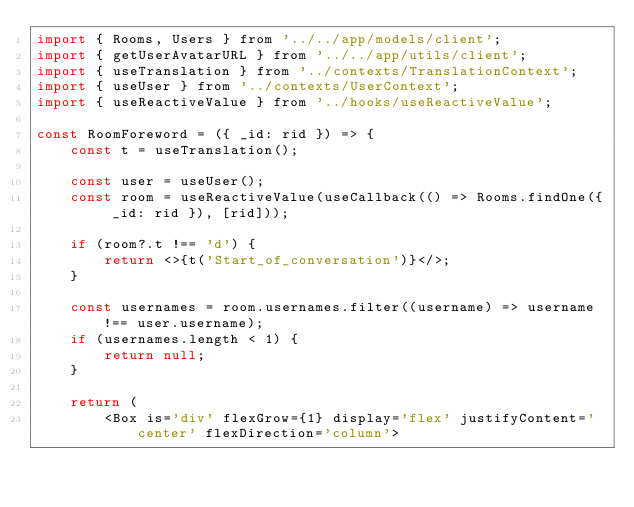Convert code to text. <code><loc_0><loc_0><loc_500><loc_500><_JavaScript_>import { Rooms, Users } from '../../app/models/client';
import { getUserAvatarURL } from '../../app/utils/client';
import { useTranslation } from '../contexts/TranslationContext';
import { useUser } from '../contexts/UserContext';
import { useReactiveValue } from '../hooks/useReactiveValue';

const RoomForeword = ({ _id: rid }) => {
	const t = useTranslation();

	const user = useUser();
	const room = useReactiveValue(useCallback(() => Rooms.findOne({ _id: rid }), [rid]));

	if (room?.t !== 'd') {
		return <>{t('Start_of_conversation')}</>;
	}

	const usernames = room.usernames.filter((username) => username !== user.username);
	if (usernames.length < 1) {
		return null;
	}

	return (
		<Box is='div' flexGrow={1} display='flex' justifyContent='center' flexDirection='column'></code> 